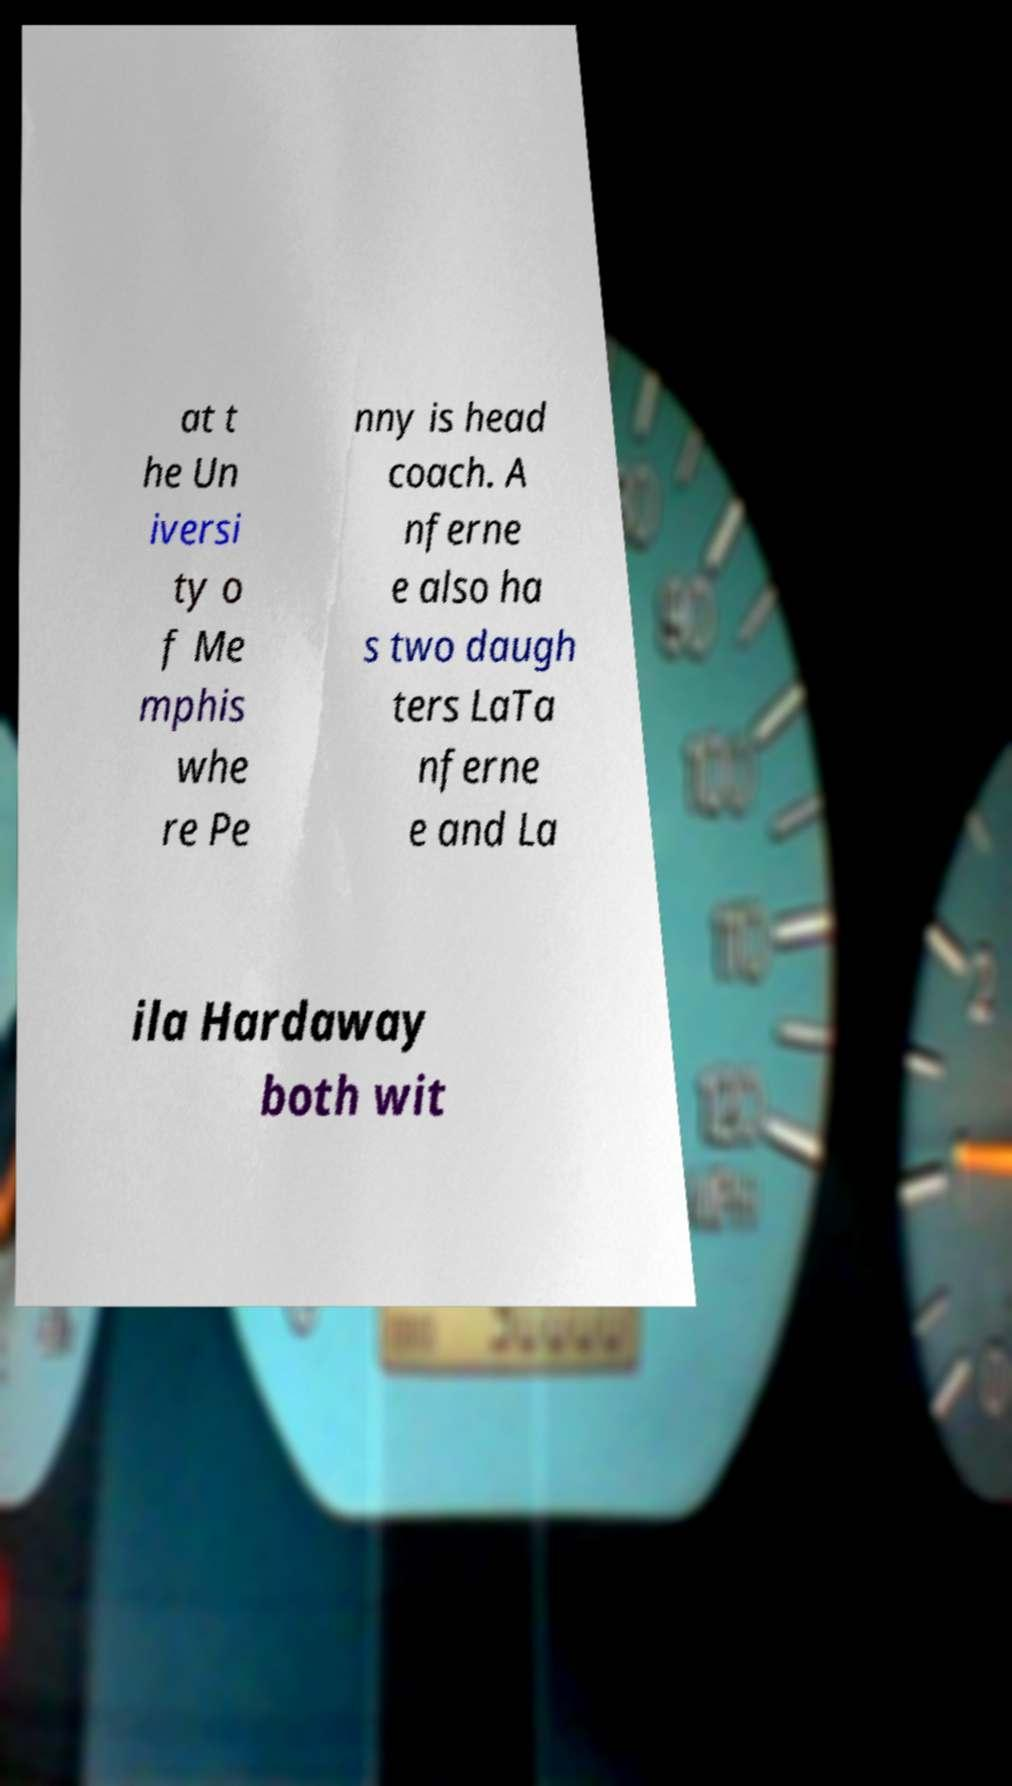Please identify and transcribe the text found in this image. at t he Un iversi ty o f Me mphis whe re Pe nny is head coach. A nferne e also ha s two daugh ters LaTa nferne e and La ila Hardaway both wit 